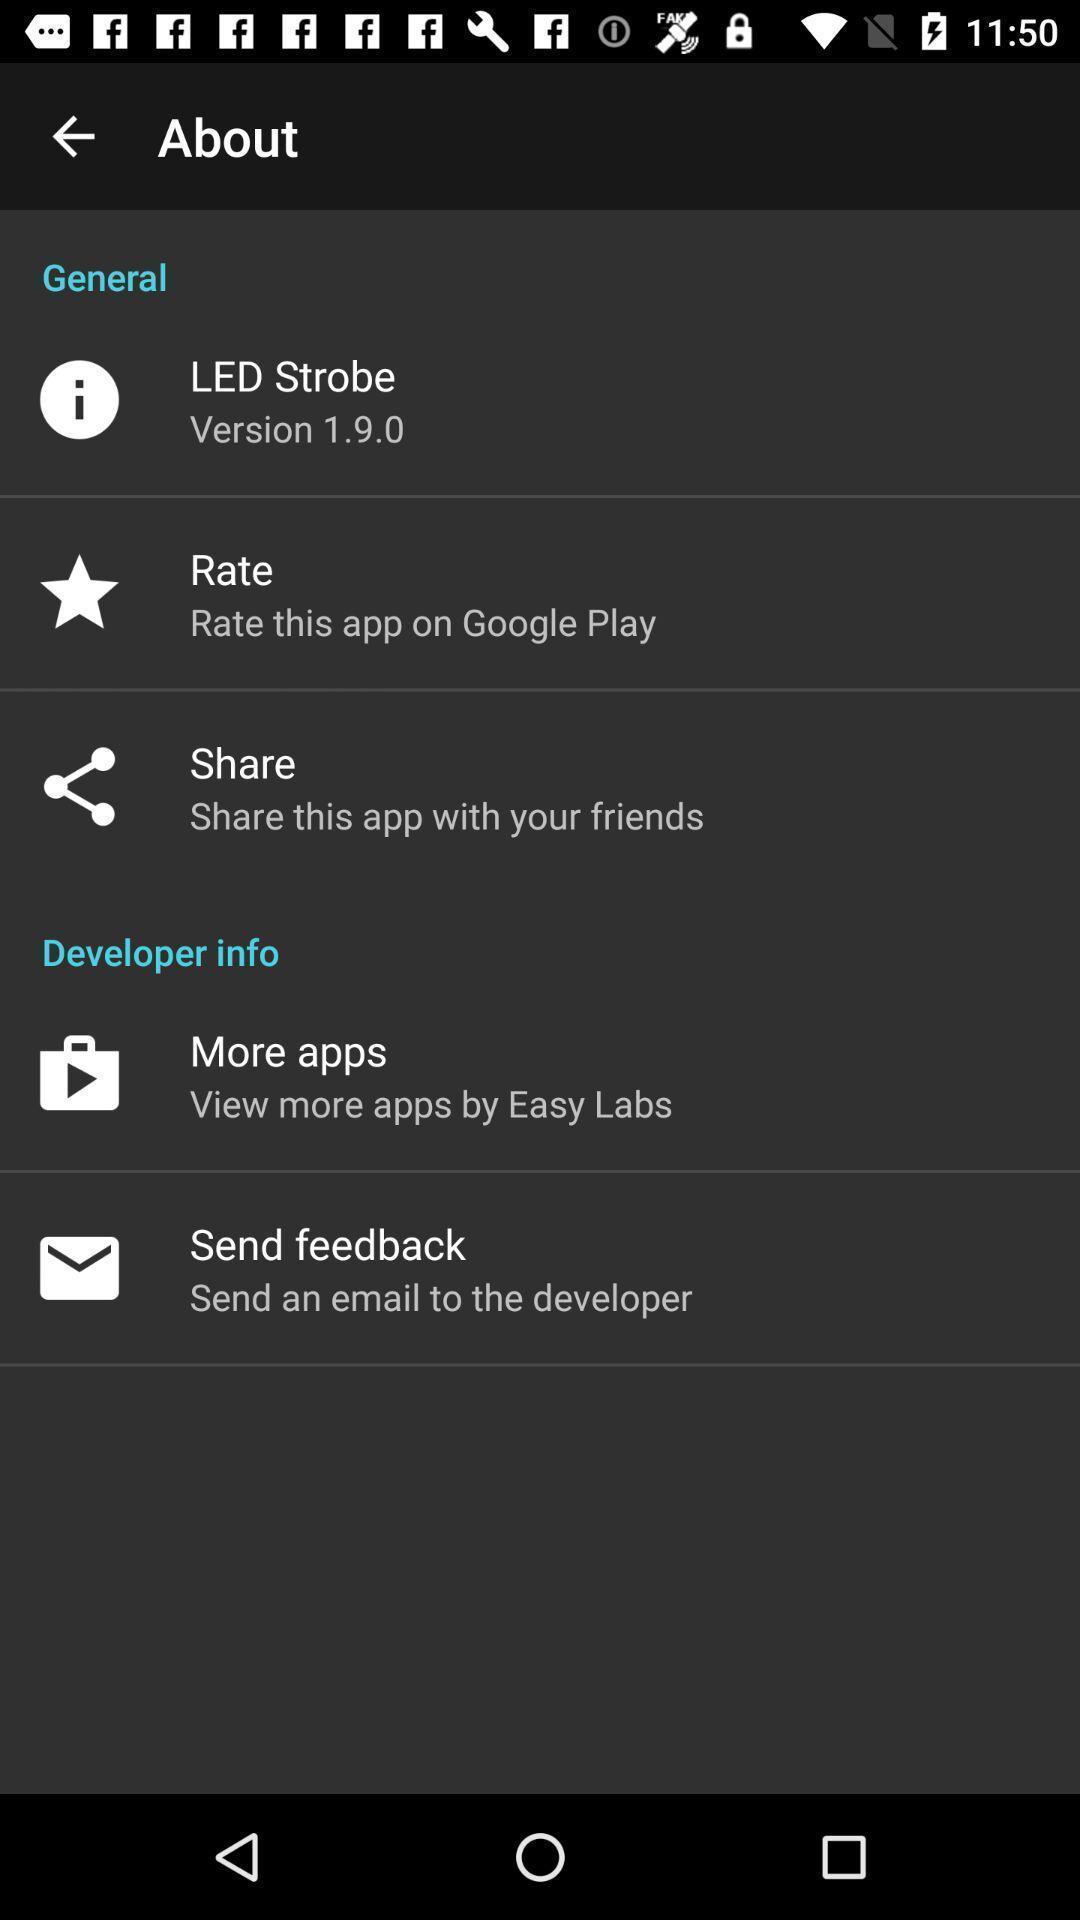What details can you identify in this image? Page shows about general information settings. 